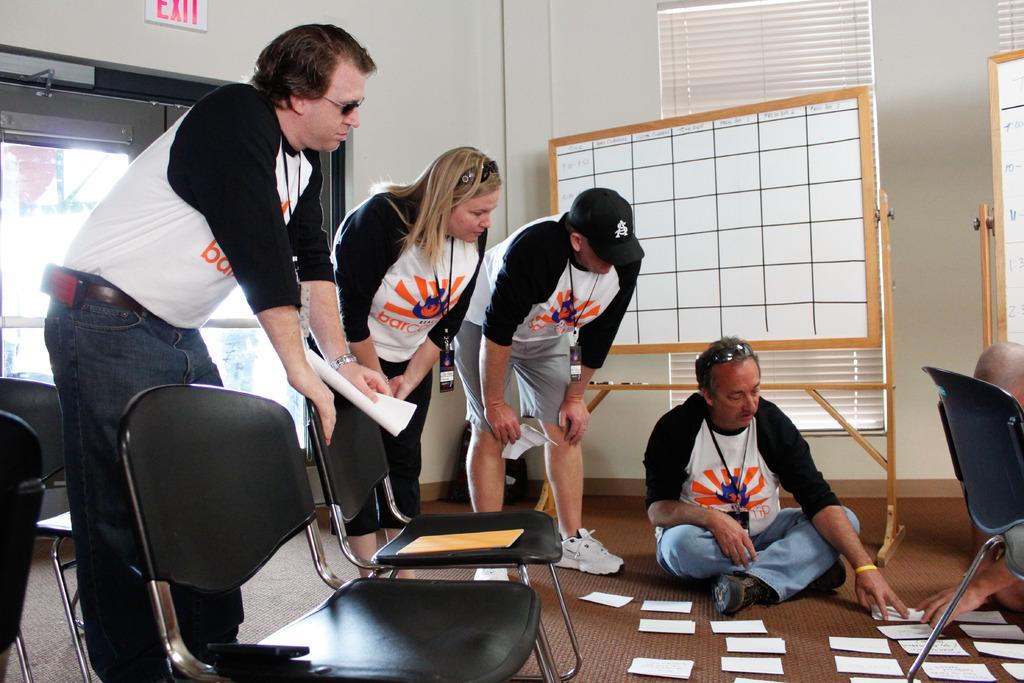In one or two sentences, can you explain what this image depicts? As we can see in the image there is a white color wall, window, chairs, few people here and there and boards. On floor there are papers. 